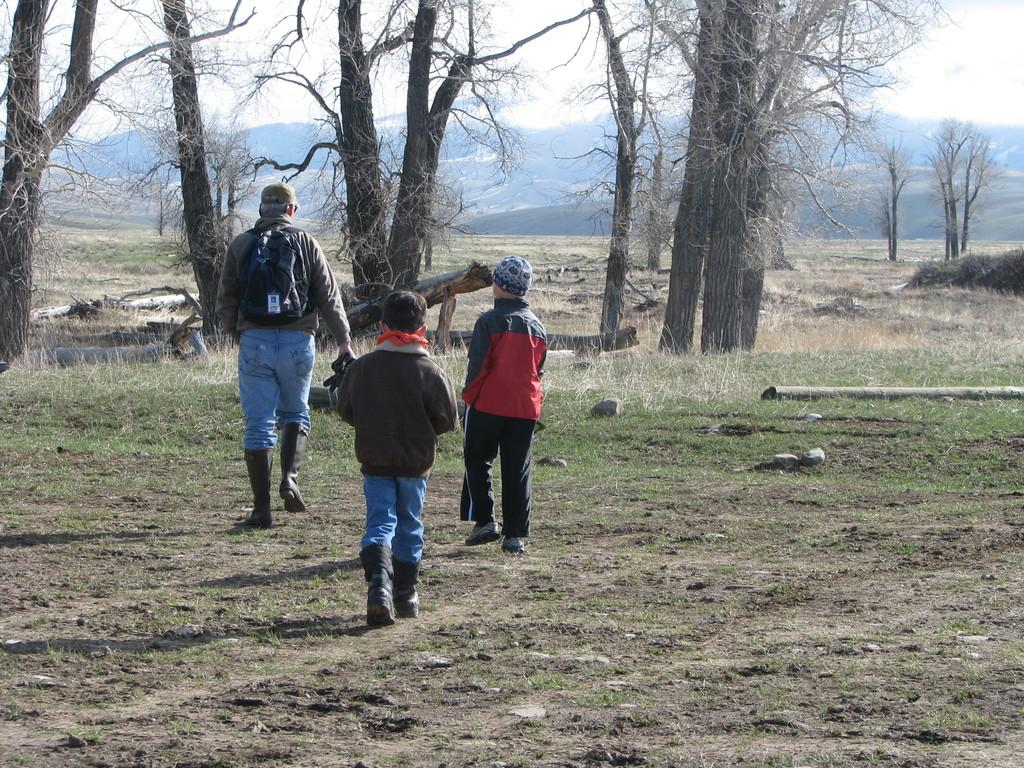How many people are in the image? There are three people in the image. What are the people wearing on their feet? The people are wearing boots. What type of headwear are two of the people wearing? Two of the people are wearing caps. What type of terrain is visible in the image? There is grass, stones, trees, and hills visible in the image. What objects can be seen in the image besides the people? There is a bag and a wooden log in the image. What is the color of the sky in the image? The sky is white in the image. What type of spoon is being used to stir the event in the image? There is no spoon or event present in the image. What statement is being made by the people in the image? The image does not depict a statement being made by the people; it simply shows them in a natural setting. 